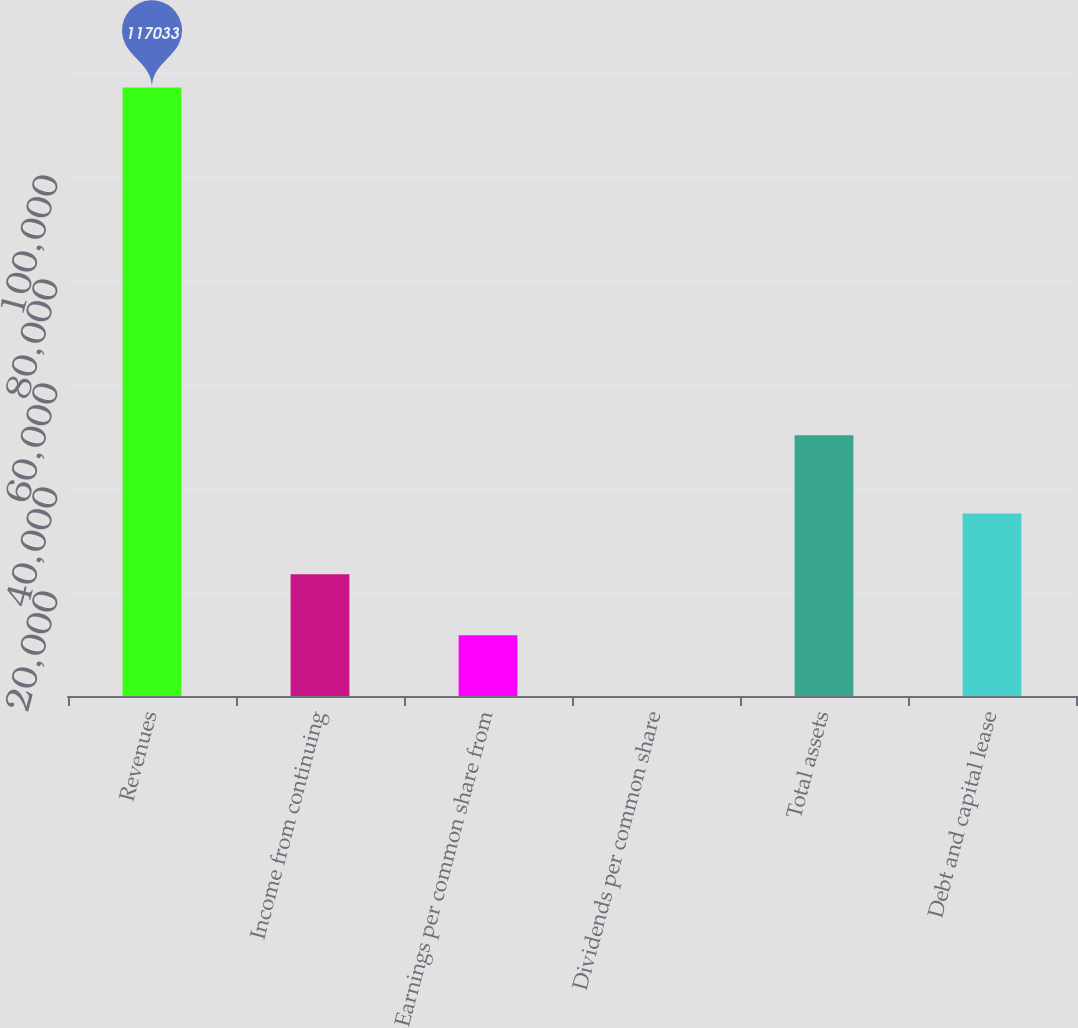Convert chart to OTSL. <chart><loc_0><loc_0><loc_500><loc_500><bar_chart><fcel>Revenues<fcel>Income from continuing<fcel>Earnings per common share from<fcel>Dividends per common share<fcel>Total assets<fcel>Debt and capital lease<nl><fcel>117033<fcel>23409.2<fcel>11706.2<fcel>3.2<fcel>50155<fcel>35112.1<nl></chart> 